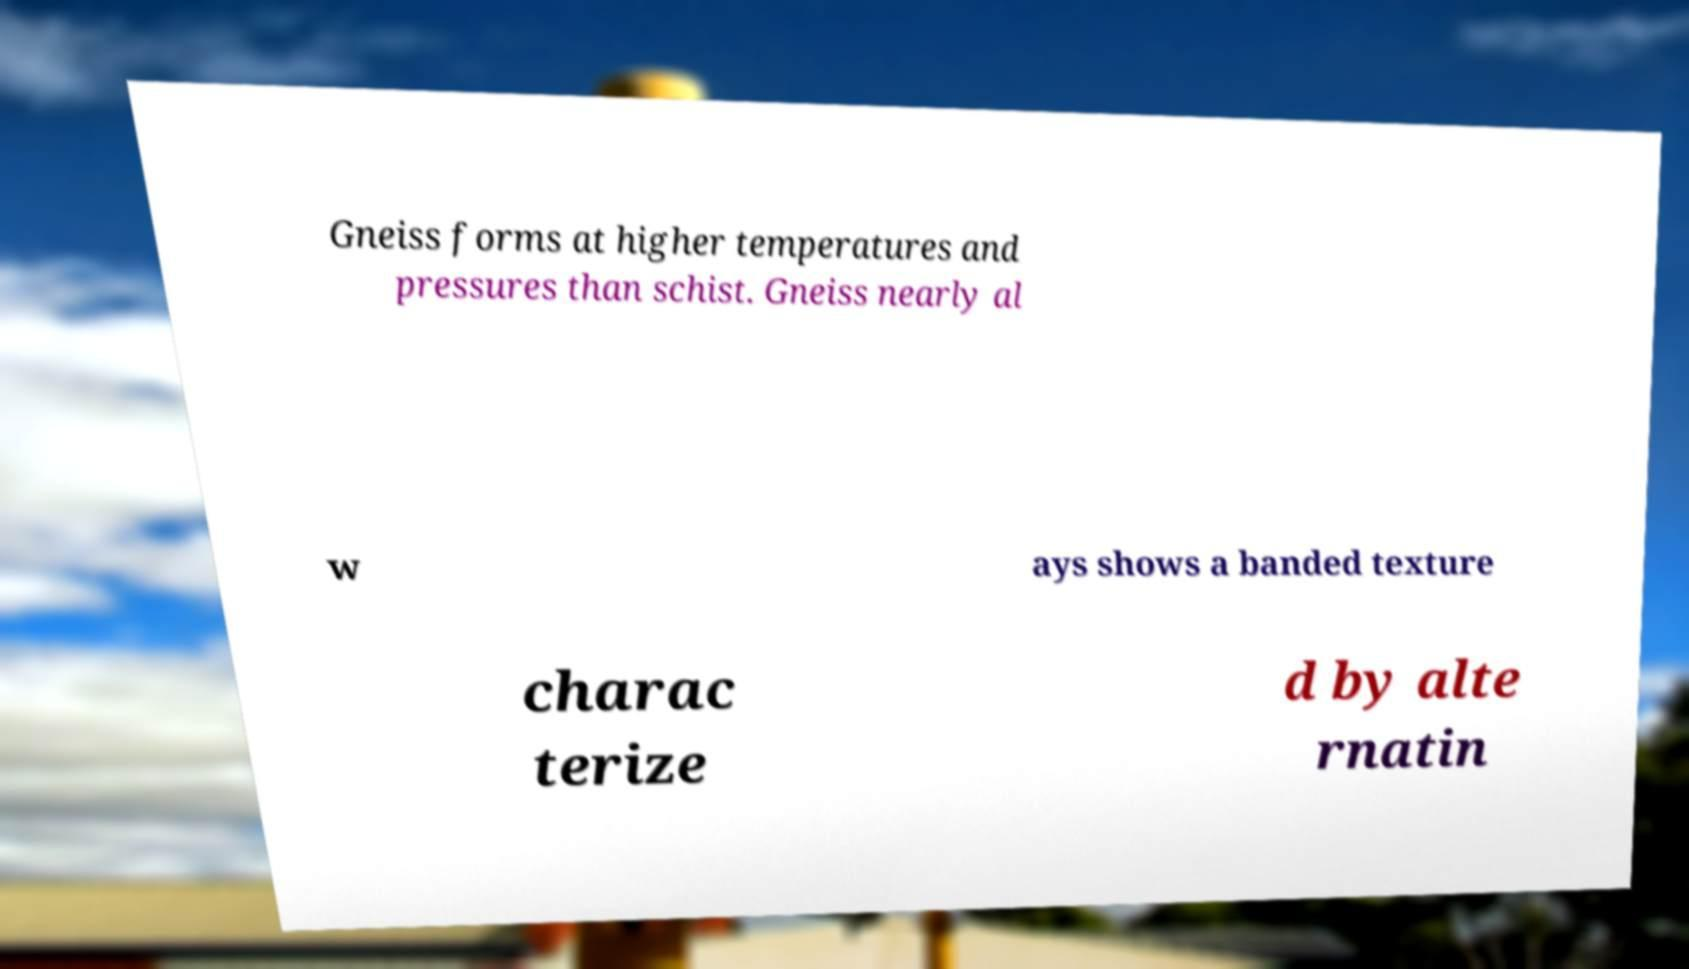Please read and relay the text visible in this image. What does it say? Gneiss forms at higher temperatures and pressures than schist. Gneiss nearly al w ays shows a banded texture charac terize d by alte rnatin 